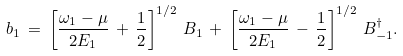Convert formula to latex. <formula><loc_0><loc_0><loc_500><loc_500>b _ { 1 } \, = \, \left [ \frac { \omega _ { 1 } - \mu } { 2 E _ { 1 } } \, + \, \frac { 1 } { 2 } \right ] ^ { 1 / 2 } \, B _ { 1 } \, + \, \left [ \frac { \omega _ { 1 } - \mu } { 2 E _ { 1 } } \, - \, \frac { 1 } { 2 } \right ] ^ { 1 / 2 } \, B _ { - 1 } ^ { \dagger } .</formula> 